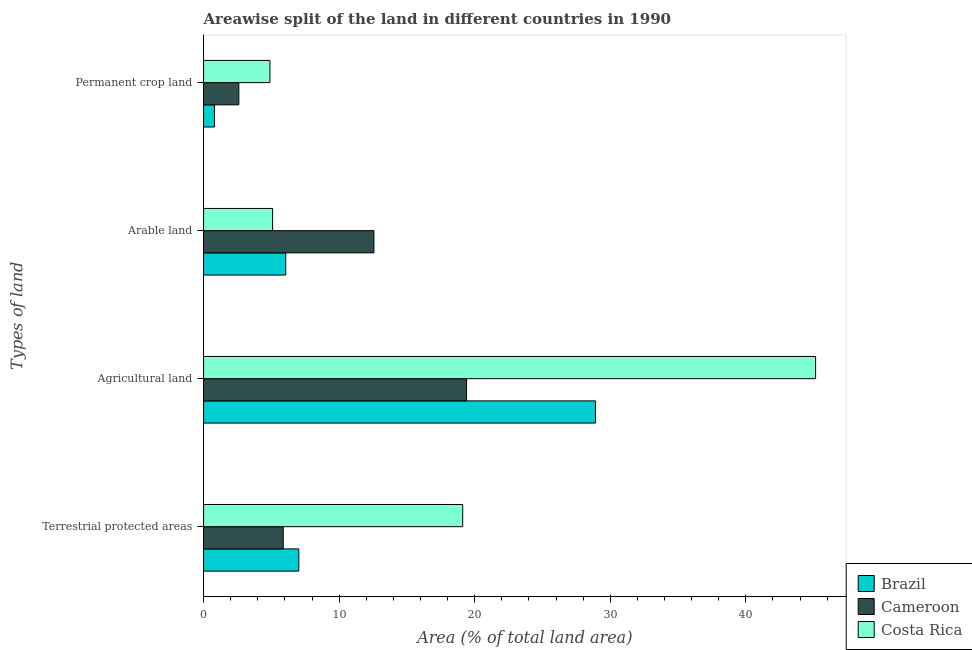How many groups of bars are there?
Provide a short and direct response. 4. How many bars are there on the 1st tick from the top?
Offer a very short reply. 3. What is the label of the 1st group of bars from the top?
Offer a very short reply. Permanent crop land. What is the percentage of land under terrestrial protection in Cameroon?
Your answer should be very brief. 5.88. Across all countries, what is the maximum percentage of area under permanent crop land?
Make the answer very short. 4.9. Across all countries, what is the minimum percentage of land under terrestrial protection?
Make the answer very short. 5.88. In which country was the percentage of area under arable land maximum?
Give a very brief answer. Cameroon. What is the total percentage of area under agricultural land in the graph?
Your answer should be compact. 93.45. What is the difference between the percentage of land under terrestrial protection in Costa Rica and that in Cameroon?
Offer a terse response. 13.24. What is the difference between the percentage of land under terrestrial protection in Brazil and the percentage of area under agricultural land in Cameroon?
Keep it short and to the point. -12.37. What is the average percentage of land under terrestrial protection per country?
Your answer should be compact. 10.67. What is the difference between the percentage of area under permanent crop land and percentage of area under agricultural land in Cameroon?
Make the answer very short. -16.8. What is the ratio of the percentage of land under terrestrial protection in Cameroon to that in Brazil?
Keep it short and to the point. 0.84. Is the percentage of area under agricultural land in Cameroon less than that in Brazil?
Ensure brevity in your answer.  Yes. Is the difference between the percentage of land under terrestrial protection in Brazil and Costa Rica greater than the difference between the percentage of area under arable land in Brazil and Costa Rica?
Provide a short and direct response. No. What is the difference between the highest and the second highest percentage of land under terrestrial protection?
Offer a very short reply. 12.09. What is the difference between the highest and the lowest percentage of area under agricultural land?
Your answer should be very brief. 25.74. In how many countries, is the percentage of area under permanent crop land greater than the average percentage of area under permanent crop land taken over all countries?
Offer a very short reply. 1. Is the sum of the percentage of area under agricultural land in Cameroon and Brazil greater than the maximum percentage of land under terrestrial protection across all countries?
Provide a short and direct response. Yes. What does the 2nd bar from the top in Permanent crop land represents?
Ensure brevity in your answer.  Cameroon. What does the 3rd bar from the bottom in Permanent crop land represents?
Provide a short and direct response. Costa Rica. Is it the case that in every country, the sum of the percentage of land under terrestrial protection and percentage of area under agricultural land is greater than the percentage of area under arable land?
Make the answer very short. Yes. How many bars are there?
Provide a short and direct response. 12. Are all the bars in the graph horizontal?
Offer a very short reply. Yes. What is the difference between two consecutive major ticks on the X-axis?
Your response must be concise. 10. Are the values on the major ticks of X-axis written in scientific E-notation?
Provide a succinct answer. No. Does the graph contain any zero values?
Give a very brief answer. No. Does the graph contain grids?
Your answer should be very brief. No. Where does the legend appear in the graph?
Your response must be concise. Bottom right. How many legend labels are there?
Provide a succinct answer. 3. What is the title of the graph?
Offer a very short reply. Areawise split of the land in different countries in 1990. Does "Least developed countries" appear as one of the legend labels in the graph?
Your answer should be very brief. No. What is the label or title of the X-axis?
Give a very brief answer. Area (% of total land area). What is the label or title of the Y-axis?
Your response must be concise. Types of land. What is the Area (% of total land area) of Brazil in Terrestrial protected areas?
Make the answer very short. 7.02. What is the Area (% of total land area) in Cameroon in Terrestrial protected areas?
Offer a very short reply. 5.88. What is the Area (% of total land area) in Costa Rica in Terrestrial protected areas?
Your response must be concise. 19.11. What is the Area (% of total land area) in Brazil in Agricultural land?
Keep it short and to the point. 28.91. What is the Area (% of total land area) of Cameroon in Agricultural land?
Your answer should be very brief. 19.4. What is the Area (% of total land area) in Costa Rica in Agricultural land?
Keep it short and to the point. 45.14. What is the Area (% of total land area) of Brazil in Arable land?
Offer a very short reply. 6.06. What is the Area (% of total land area) of Cameroon in Arable land?
Provide a short and direct response. 12.57. What is the Area (% of total land area) of Costa Rica in Arable land?
Offer a very short reply. 5.09. What is the Area (% of total land area) in Brazil in Permanent crop land?
Give a very brief answer. 0.8. What is the Area (% of total land area) of Cameroon in Permanent crop land?
Your answer should be compact. 2.6. What is the Area (% of total land area) of Costa Rica in Permanent crop land?
Provide a short and direct response. 4.9. Across all Types of land, what is the maximum Area (% of total land area) of Brazil?
Your answer should be compact. 28.91. Across all Types of land, what is the maximum Area (% of total land area) of Cameroon?
Your answer should be very brief. 19.4. Across all Types of land, what is the maximum Area (% of total land area) in Costa Rica?
Provide a succinct answer. 45.14. Across all Types of land, what is the minimum Area (% of total land area) of Brazil?
Give a very brief answer. 0.8. Across all Types of land, what is the minimum Area (% of total land area) of Cameroon?
Give a very brief answer. 2.6. Across all Types of land, what is the minimum Area (% of total land area) of Costa Rica?
Offer a very short reply. 4.9. What is the total Area (% of total land area) in Brazil in the graph?
Ensure brevity in your answer.  42.8. What is the total Area (% of total land area) in Cameroon in the graph?
Provide a short and direct response. 40.44. What is the total Area (% of total land area) of Costa Rica in the graph?
Your response must be concise. 74.24. What is the difference between the Area (% of total land area) in Brazil in Terrestrial protected areas and that in Agricultural land?
Give a very brief answer. -21.88. What is the difference between the Area (% of total land area) in Cameroon in Terrestrial protected areas and that in Agricultural land?
Provide a short and direct response. -13.52. What is the difference between the Area (% of total land area) in Costa Rica in Terrestrial protected areas and that in Agricultural land?
Give a very brief answer. -26.03. What is the difference between the Area (% of total land area) in Brazil in Terrestrial protected areas and that in Arable land?
Your answer should be very brief. 0.96. What is the difference between the Area (% of total land area) of Cameroon in Terrestrial protected areas and that in Arable land?
Offer a very short reply. -6.69. What is the difference between the Area (% of total land area) of Costa Rica in Terrestrial protected areas and that in Arable land?
Make the answer very short. 14.02. What is the difference between the Area (% of total land area) of Brazil in Terrestrial protected areas and that in Permanent crop land?
Provide a short and direct response. 6.22. What is the difference between the Area (% of total land area) of Cameroon in Terrestrial protected areas and that in Permanent crop land?
Keep it short and to the point. 3.27. What is the difference between the Area (% of total land area) in Costa Rica in Terrestrial protected areas and that in Permanent crop land?
Provide a succinct answer. 14.22. What is the difference between the Area (% of total land area) in Brazil in Agricultural land and that in Arable land?
Your answer should be very brief. 22.84. What is the difference between the Area (% of total land area) of Cameroon in Agricultural land and that in Arable land?
Your answer should be very brief. 6.83. What is the difference between the Area (% of total land area) of Costa Rica in Agricultural land and that in Arable land?
Your answer should be very brief. 40.05. What is the difference between the Area (% of total land area) of Brazil in Agricultural land and that in Permanent crop land?
Your response must be concise. 28.1. What is the difference between the Area (% of total land area) of Cameroon in Agricultural land and that in Permanent crop land?
Keep it short and to the point. 16.8. What is the difference between the Area (% of total land area) of Costa Rica in Agricultural land and that in Permanent crop land?
Your answer should be compact. 40.25. What is the difference between the Area (% of total land area) in Brazil in Arable land and that in Permanent crop land?
Offer a terse response. 5.26. What is the difference between the Area (% of total land area) in Cameroon in Arable land and that in Permanent crop land?
Provide a short and direct response. 9.96. What is the difference between the Area (% of total land area) of Costa Rica in Arable land and that in Permanent crop land?
Your response must be concise. 0.2. What is the difference between the Area (% of total land area) in Brazil in Terrestrial protected areas and the Area (% of total land area) in Cameroon in Agricultural land?
Offer a terse response. -12.37. What is the difference between the Area (% of total land area) of Brazil in Terrestrial protected areas and the Area (% of total land area) of Costa Rica in Agricultural land?
Offer a terse response. -38.12. What is the difference between the Area (% of total land area) in Cameroon in Terrestrial protected areas and the Area (% of total land area) in Costa Rica in Agricultural land?
Give a very brief answer. -39.27. What is the difference between the Area (% of total land area) of Brazil in Terrestrial protected areas and the Area (% of total land area) of Cameroon in Arable land?
Your response must be concise. -5.54. What is the difference between the Area (% of total land area) of Brazil in Terrestrial protected areas and the Area (% of total land area) of Costa Rica in Arable land?
Keep it short and to the point. 1.93. What is the difference between the Area (% of total land area) of Cameroon in Terrestrial protected areas and the Area (% of total land area) of Costa Rica in Arable land?
Give a very brief answer. 0.78. What is the difference between the Area (% of total land area) of Brazil in Terrestrial protected areas and the Area (% of total land area) of Cameroon in Permanent crop land?
Give a very brief answer. 4.42. What is the difference between the Area (% of total land area) of Brazil in Terrestrial protected areas and the Area (% of total land area) of Costa Rica in Permanent crop land?
Give a very brief answer. 2.13. What is the difference between the Area (% of total land area) of Cameroon in Terrestrial protected areas and the Area (% of total land area) of Costa Rica in Permanent crop land?
Your answer should be compact. 0.98. What is the difference between the Area (% of total land area) in Brazil in Agricultural land and the Area (% of total land area) in Cameroon in Arable land?
Give a very brief answer. 16.34. What is the difference between the Area (% of total land area) in Brazil in Agricultural land and the Area (% of total land area) in Costa Rica in Arable land?
Provide a short and direct response. 23.81. What is the difference between the Area (% of total land area) in Cameroon in Agricultural land and the Area (% of total land area) in Costa Rica in Arable land?
Give a very brief answer. 14.31. What is the difference between the Area (% of total land area) in Brazil in Agricultural land and the Area (% of total land area) in Cameroon in Permanent crop land?
Keep it short and to the point. 26.3. What is the difference between the Area (% of total land area) in Brazil in Agricultural land and the Area (% of total land area) in Costa Rica in Permanent crop land?
Offer a terse response. 24.01. What is the difference between the Area (% of total land area) of Cameroon in Agricultural land and the Area (% of total land area) of Costa Rica in Permanent crop land?
Offer a very short reply. 14.5. What is the difference between the Area (% of total land area) of Brazil in Arable land and the Area (% of total land area) of Cameroon in Permanent crop land?
Provide a succinct answer. 3.46. What is the difference between the Area (% of total land area) of Brazil in Arable land and the Area (% of total land area) of Costa Rica in Permanent crop land?
Give a very brief answer. 1.17. What is the difference between the Area (% of total land area) of Cameroon in Arable land and the Area (% of total land area) of Costa Rica in Permanent crop land?
Keep it short and to the point. 7.67. What is the average Area (% of total land area) of Brazil per Types of land?
Your response must be concise. 10.7. What is the average Area (% of total land area) of Cameroon per Types of land?
Offer a very short reply. 10.11. What is the average Area (% of total land area) of Costa Rica per Types of land?
Ensure brevity in your answer.  18.56. What is the difference between the Area (% of total land area) of Brazil and Area (% of total land area) of Cameroon in Terrestrial protected areas?
Provide a succinct answer. 1.15. What is the difference between the Area (% of total land area) in Brazil and Area (% of total land area) in Costa Rica in Terrestrial protected areas?
Keep it short and to the point. -12.09. What is the difference between the Area (% of total land area) of Cameroon and Area (% of total land area) of Costa Rica in Terrestrial protected areas?
Your answer should be very brief. -13.24. What is the difference between the Area (% of total land area) in Brazil and Area (% of total land area) in Cameroon in Agricultural land?
Keep it short and to the point. 9.51. What is the difference between the Area (% of total land area) in Brazil and Area (% of total land area) in Costa Rica in Agricultural land?
Provide a succinct answer. -16.24. What is the difference between the Area (% of total land area) of Cameroon and Area (% of total land area) of Costa Rica in Agricultural land?
Make the answer very short. -25.74. What is the difference between the Area (% of total land area) of Brazil and Area (% of total land area) of Cameroon in Arable land?
Provide a succinct answer. -6.5. What is the difference between the Area (% of total land area) in Brazil and Area (% of total land area) in Costa Rica in Arable land?
Your response must be concise. 0.97. What is the difference between the Area (% of total land area) of Cameroon and Area (% of total land area) of Costa Rica in Arable land?
Offer a terse response. 7.47. What is the difference between the Area (% of total land area) of Brazil and Area (% of total land area) of Cameroon in Permanent crop land?
Offer a terse response. -1.8. What is the difference between the Area (% of total land area) of Brazil and Area (% of total land area) of Costa Rica in Permanent crop land?
Make the answer very short. -4.09. What is the difference between the Area (% of total land area) of Cameroon and Area (% of total land area) of Costa Rica in Permanent crop land?
Ensure brevity in your answer.  -2.29. What is the ratio of the Area (% of total land area) of Brazil in Terrestrial protected areas to that in Agricultural land?
Give a very brief answer. 0.24. What is the ratio of the Area (% of total land area) of Cameroon in Terrestrial protected areas to that in Agricultural land?
Offer a very short reply. 0.3. What is the ratio of the Area (% of total land area) of Costa Rica in Terrestrial protected areas to that in Agricultural land?
Your answer should be compact. 0.42. What is the ratio of the Area (% of total land area) of Brazil in Terrestrial protected areas to that in Arable land?
Your response must be concise. 1.16. What is the ratio of the Area (% of total land area) in Cameroon in Terrestrial protected areas to that in Arable land?
Give a very brief answer. 0.47. What is the ratio of the Area (% of total land area) in Costa Rica in Terrestrial protected areas to that in Arable land?
Your answer should be very brief. 3.75. What is the ratio of the Area (% of total land area) of Brazil in Terrestrial protected areas to that in Permanent crop land?
Offer a terse response. 8.73. What is the ratio of the Area (% of total land area) of Cameroon in Terrestrial protected areas to that in Permanent crop land?
Keep it short and to the point. 2.26. What is the ratio of the Area (% of total land area) of Costa Rica in Terrestrial protected areas to that in Permanent crop land?
Provide a succinct answer. 3.9. What is the ratio of the Area (% of total land area) in Brazil in Agricultural land to that in Arable land?
Offer a very short reply. 4.77. What is the ratio of the Area (% of total land area) of Cameroon in Agricultural land to that in Arable land?
Your response must be concise. 1.54. What is the ratio of the Area (% of total land area) of Costa Rica in Agricultural land to that in Arable land?
Offer a terse response. 8.87. What is the ratio of the Area (% of total land area) of Brazil in Agricultural land to that in Permanent crop land?
Keep it short and to the point. 35.92. What is the ratio of the Area (% of total land area) in Cameroon in Agricultural land to that in Permanent crop land?
Offer a terse response. 7.46. What is the ratio of the Area (% of total land area) of Costa Rica in Agricultural land to that in Permanent crop land?
Provide a short and direct response. 9.22. What is the ratio of the Area (% of total land area) of Brazil in Arable land to that in Permanent crop land?
Make the answer very short. 7.53. What is the ratio of the Area (% of total land area) in Cameroon in Arable land to that in Permanent crop land?
Provide a short and direct response. 4.83. What is the ratio of the Area (% of total land area) of Costa Rica in Arable land to that in Permanent crop land?
Ensure brevity in your answer.  1.04. What is the difference between the highest and the second highest Area (% of total land area) in Brazil?
Provide a short and direct response. 21.88. What is the difference between the highest and the second highest Area (% of total land area) in Cameroon?
Your answer should be very brief. 6.83. What is the difference between the highest and the second highest Area (% of total land area) of Costa Rica?
Offer a very short reply. 26.03. What is the difference between the highest and the lowest Area (% of total land area) of Brazil?
Offer a terse response. 28.1. What is the difference between the highest and the lowest Area (% of total land area) in Cameroon?
Keep it short and to the point. 16.8. What is the difference between the highest and the lowest Area (% of total land area) in Costa Rica?
Your answer should be compact. 40.25. 